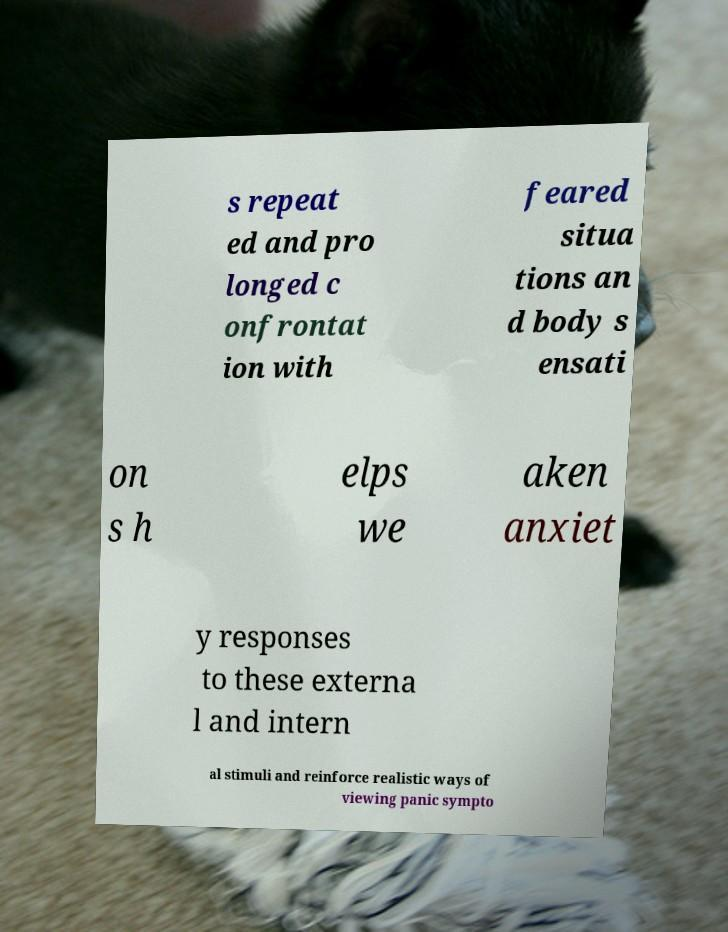For documentation purposes, I need the text within this image transcribed. Could you provide that? s repeat ed and pro longed c onfrontat ion with feared situa tions an d body s ensati on s h elps we aken anxiet y responses to these externa l and intern al stimuli and reinforce realistic ways of viewing panic sympto 